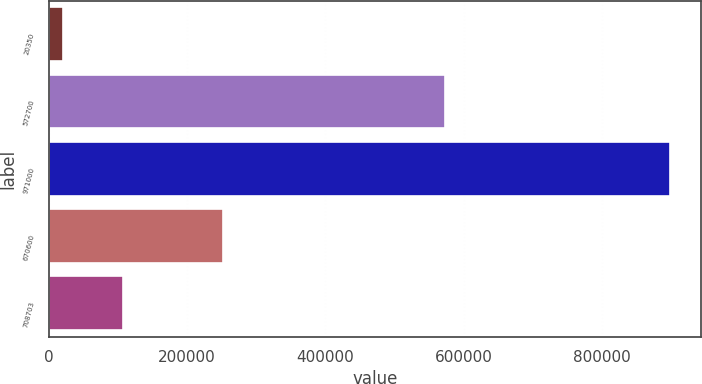Convert chart. <chart><loc_0><loc_0><loc_500><loc_500><bar_chart><fcel>20350<fcel>572700<fcel>971000<fcel>670600<fcel>708703<nl><fcel>20350<fcel>572700<fcel>898100<fcel>252720<fcel>108125<nl></chart> 